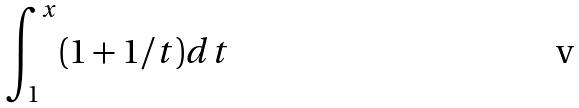Convert formula to latex. <formula><loc_0><loc_0><loc_500><loc_500>\int _ { 1 } ^ { x } ( 1 + 1 / t ) d t</formula> 